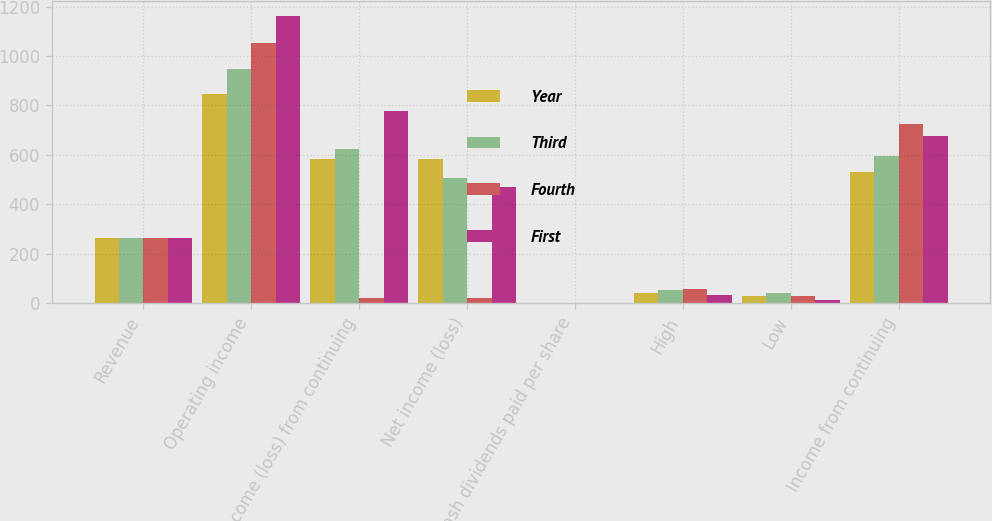<chart> <loc_0><loc_0><loc_500><loc_500><stacked_bar_chart><ecel><fcel>Revenue<fcel>Operating income<fcel>Income (loss) from continuing<fcel>Net income (loss)<fcel>Cash dividends paid per share<fcel>High<fcel>Low<fcel>Income from continuing<nl><fcel>Year<fcel>261.69<fcel>847<fcel>583<fcel>584<fcel>0.09<fcel>39.98<fcel>30<fcel>529<nl><fcel>Third<fcel>261.69<fcel>949<fcel>623<fcel>507<fcel>0.09<fcel>53.97<fcel>38.56<fcel>595<nl><fcel>Fourth<fcel>261.69<fcel>1051<fcel>21<fcel>21<fcel>0.09<fcel>55.38<fcel>29<fcel>726<nl><fcel>First<fcel>261.69<fcel>1163<fcel>776<fcel>468<fcel>0.09<fcel>32.09<fcel>12.8<fcel>674<nl></chart> 